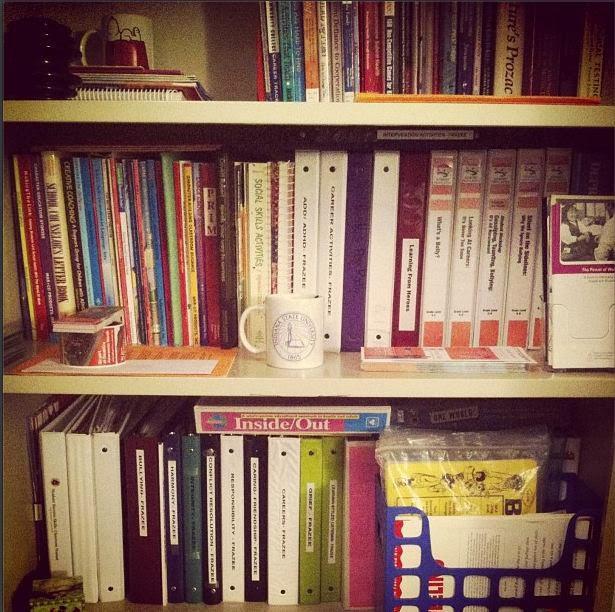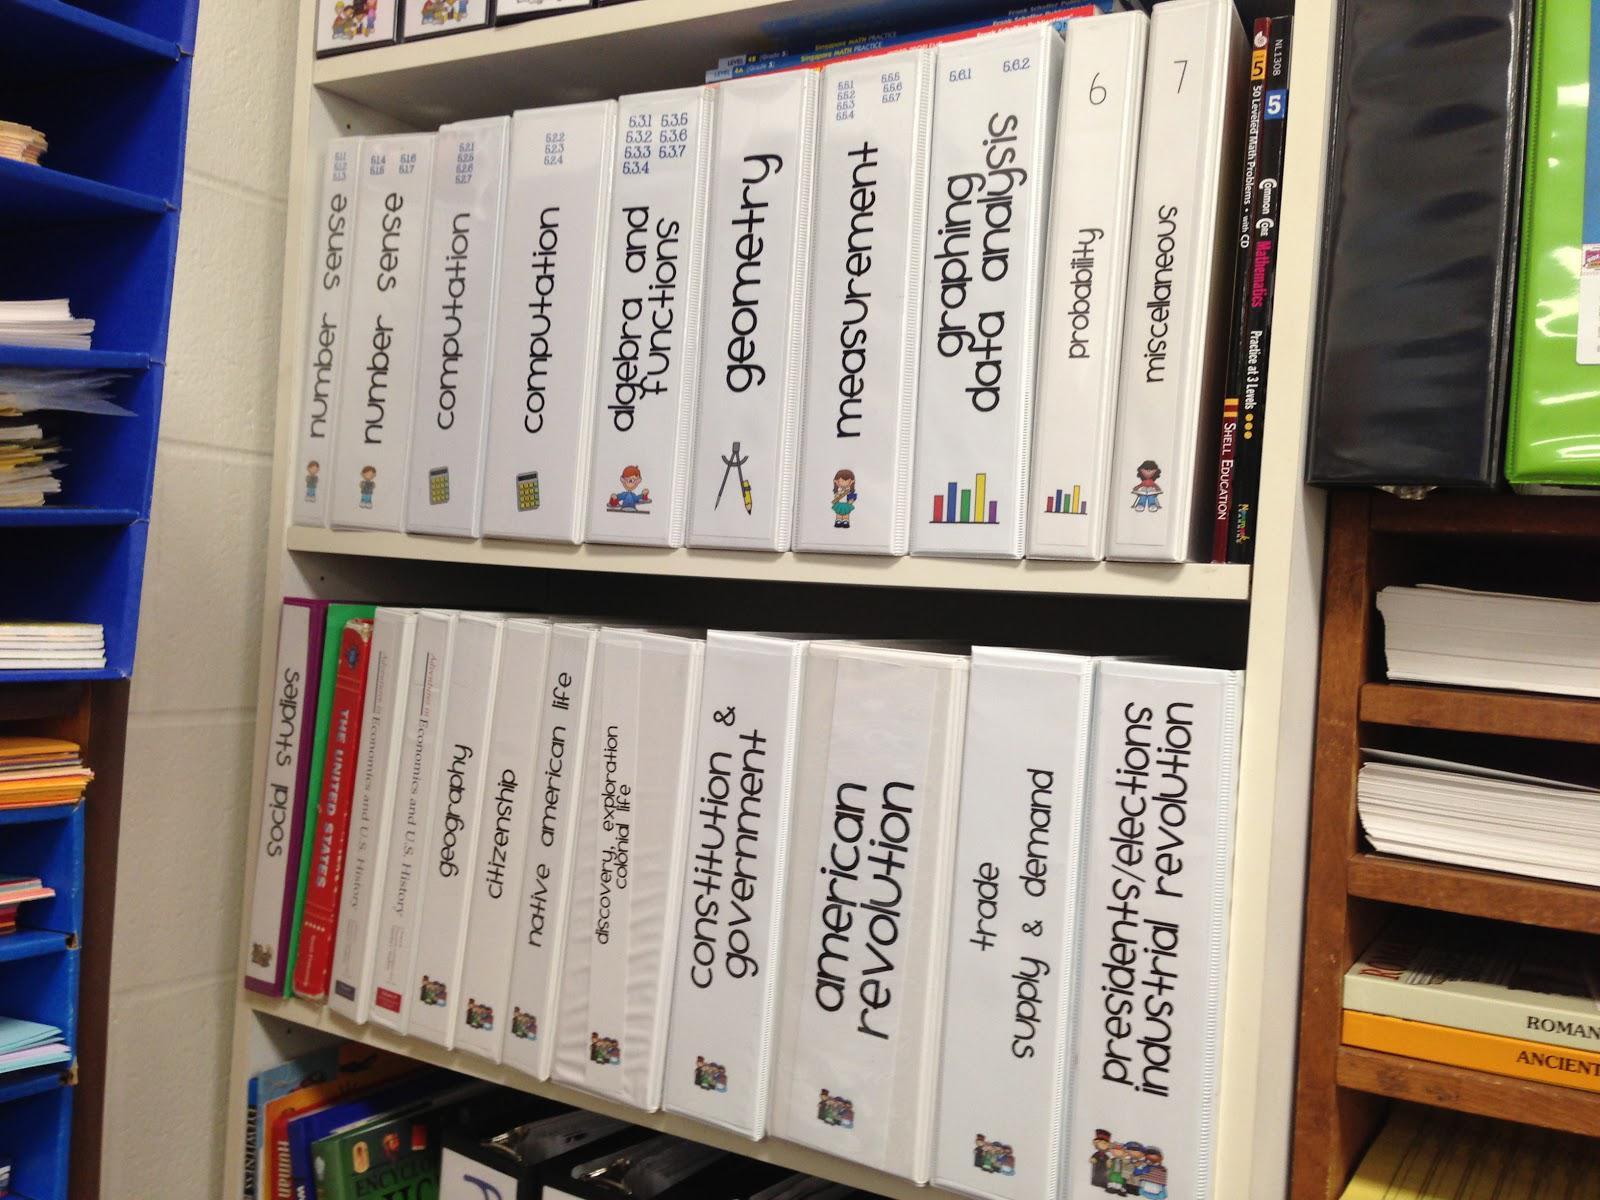The first image is the image on the left, the second image is the image on the right. Given the left and right images, does the statement "There is one open binder in the right image." hold true? Answer yes or no. No. 